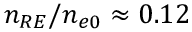<formula> <loc_0><loc_0><loc_500><loc_500>n _ { R E } / n _ { e 0 } \approx 0 . 1 2</formula> 